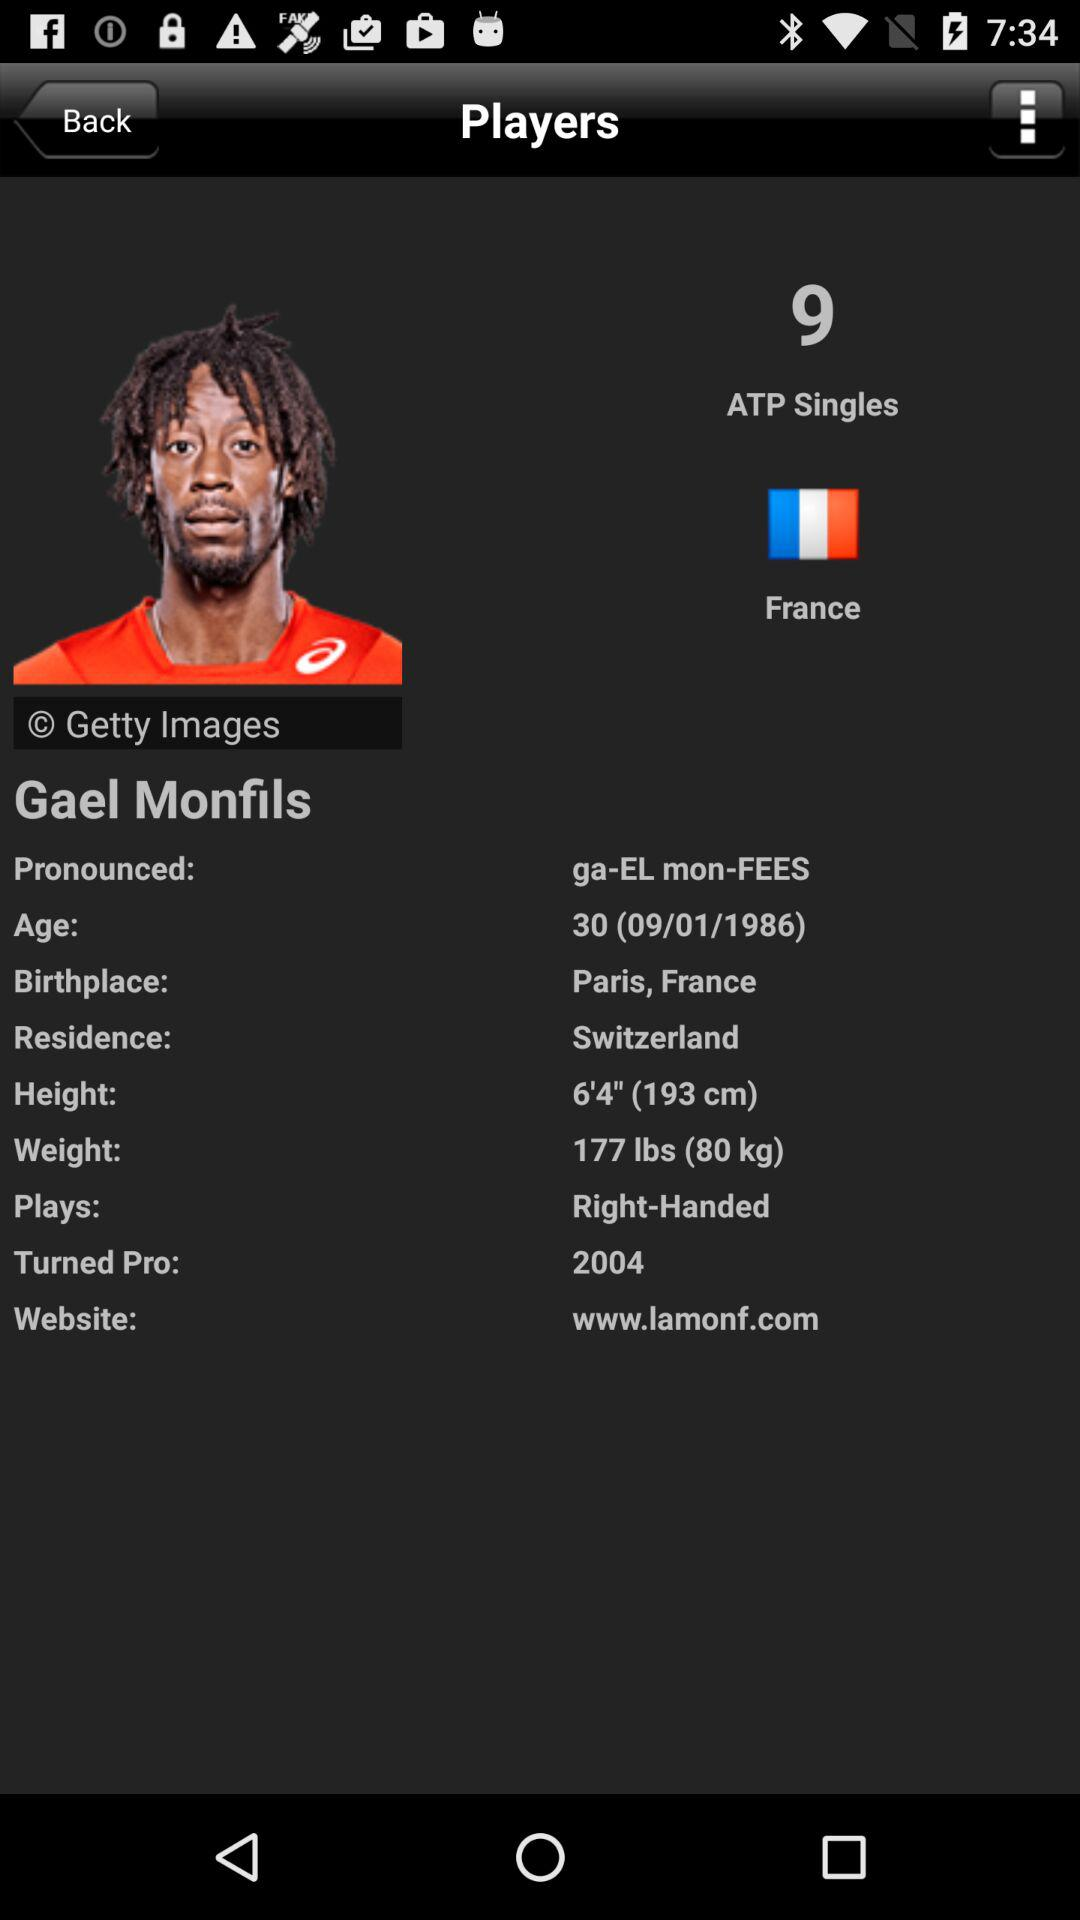What is the birthplace of the player? The birth place of the player is Paris, France. 